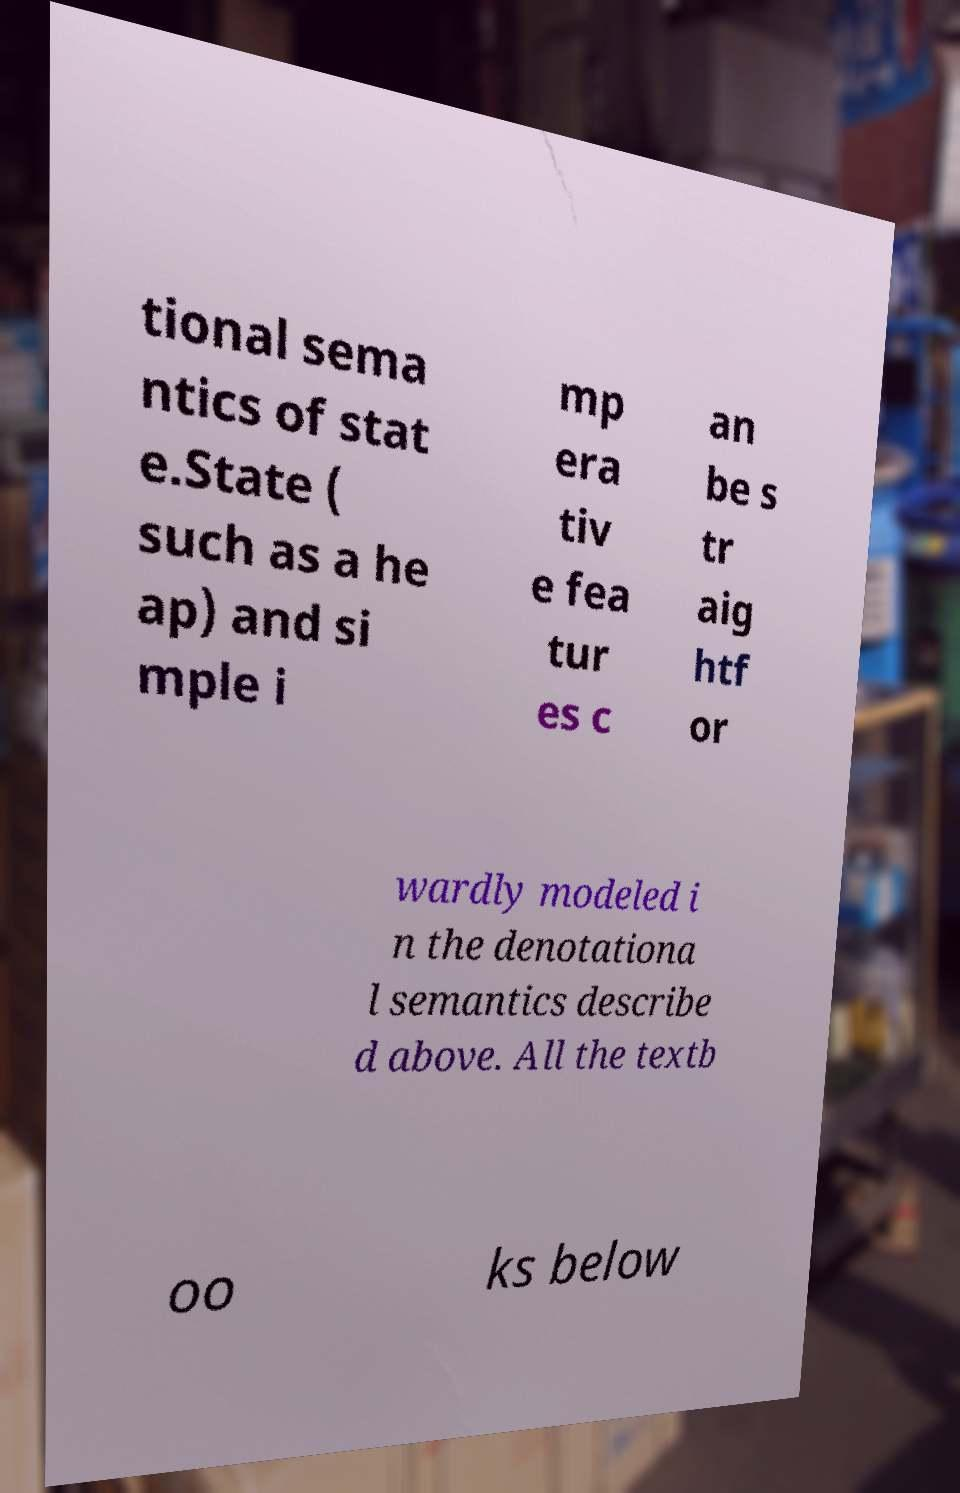Can you read and provide the text displayed in the image?This photo seems to have some interesting text. Can you extract and type it out for me? tional sema ntics of stat e.State ( such as a he ap) and si mple i mp era tiv e fea tur es c an be s tr aig htf or wardly modeled i n the denotationa l semantics describe d above. All the textb oo ks below 